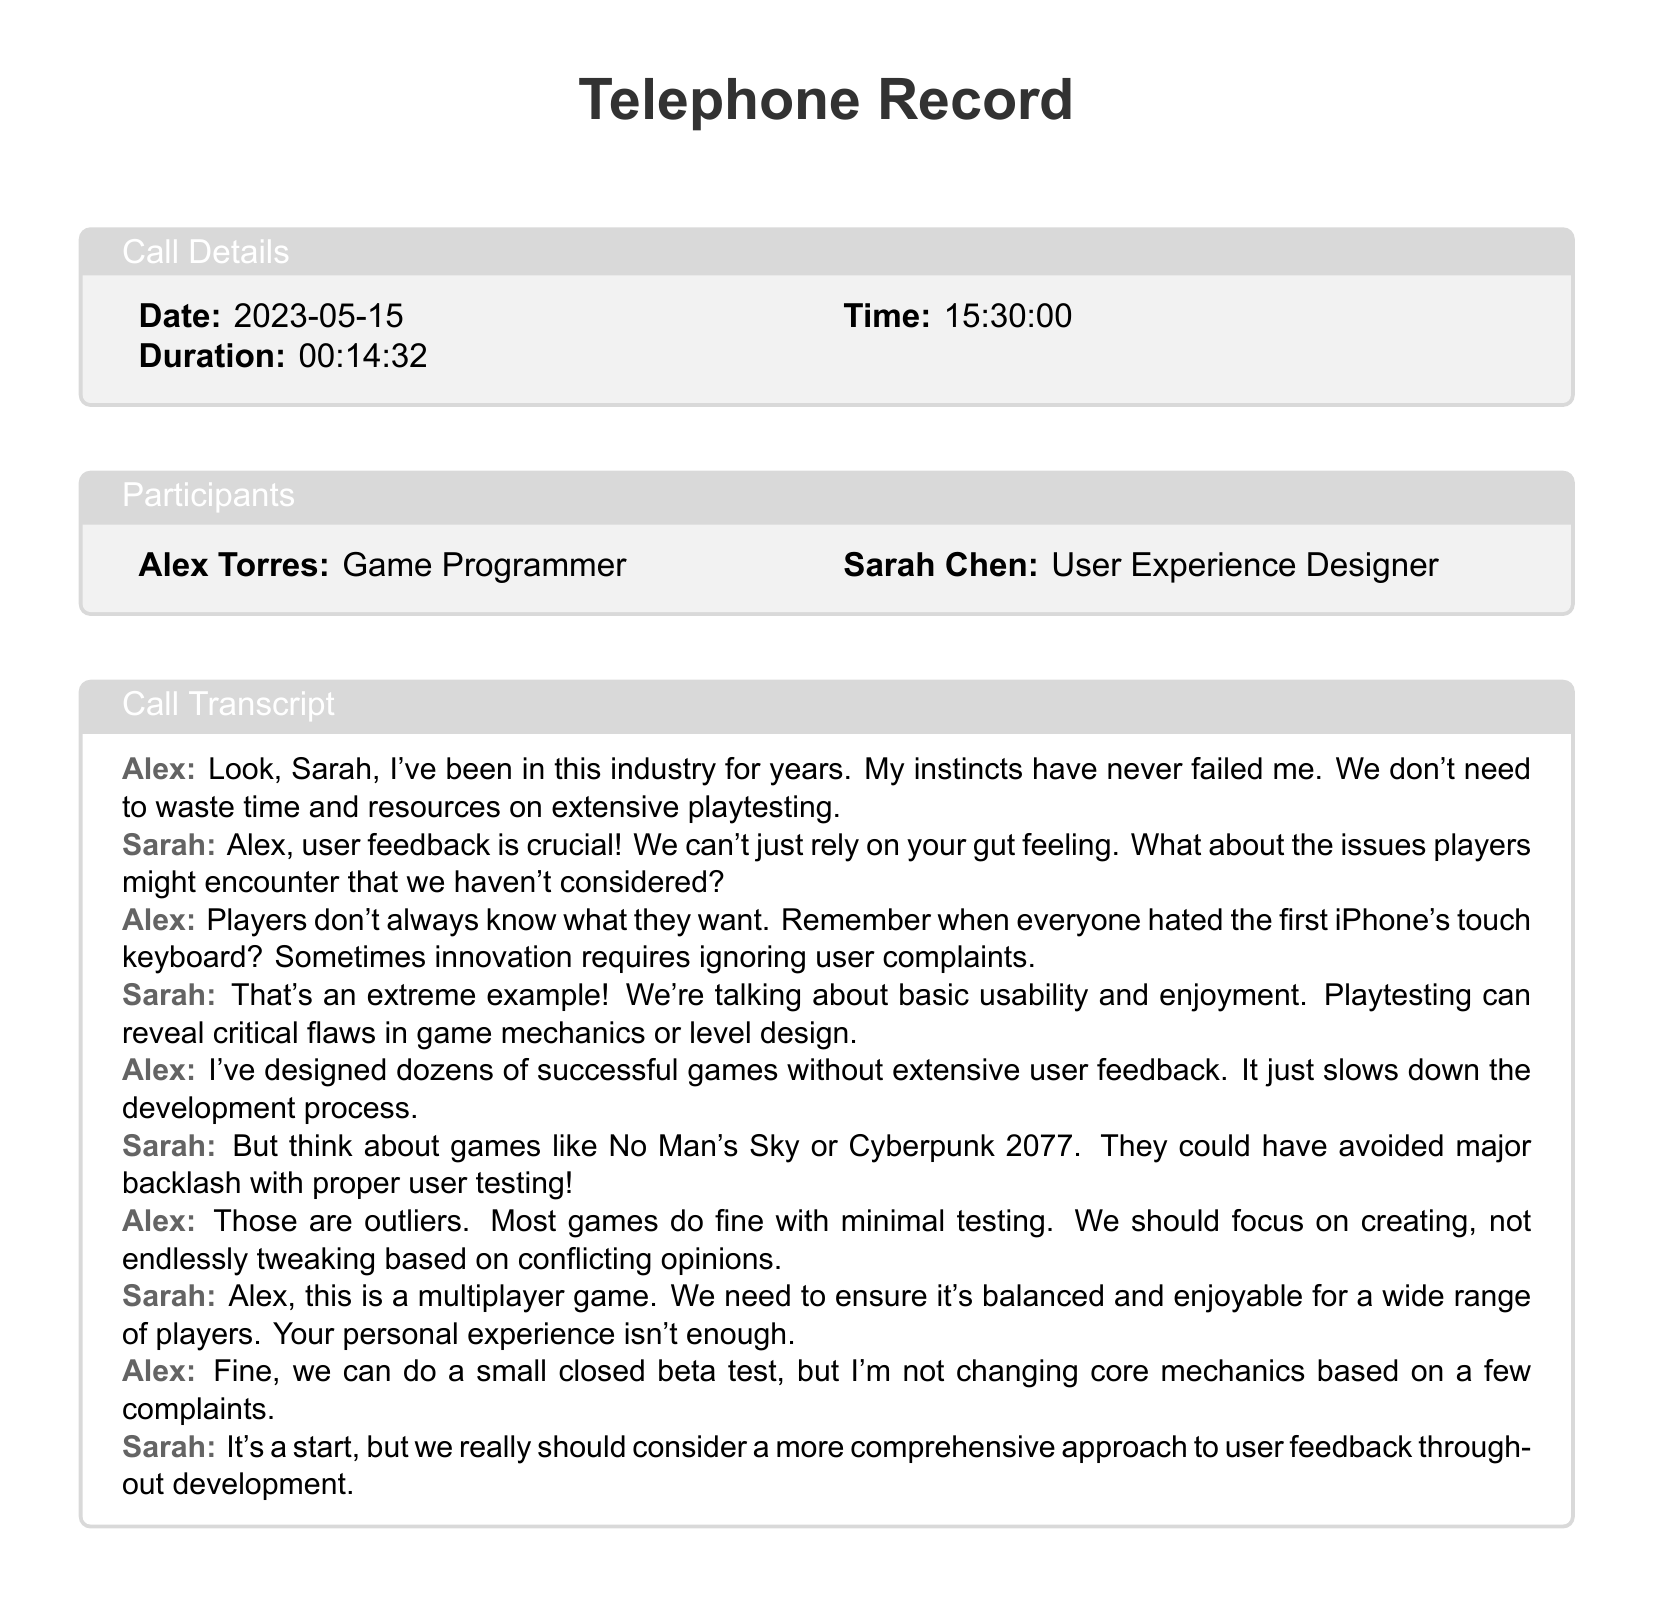What is the date of the call? The date of the call is stated in the call details section of the document.
Answer: 2023-05-15 Who are the participants in the call? The participants are listed in the participants section of the document.
Answer: Alex Torres and Sarah Chen What is the duration of the call? The duration of the call is mentioned in the call details section.
Answer: 00:14:32 What is Alex's profession? Alex's profession is identified in the participants section.
Answer: Game Programmer What major games did Sarah reference to support her argument? Sarah references these games to highlight the importance of user feedback in game development.
Answer: No Man's Sky and Cyberpunk 2077 What does Alex believe about user feedback? Alex expresses his belief about the necessity of user feedback during the argument.
Answer: Overrated What is Sarah's main concern regarding the game development process? Sarah articulates her concern about ensuring balance and enjoyment for players.
Answer: Game balance and enjoyment What approach did Alex agree to consider? Alex suggests a limited testing approach instead of extensive user feedback.
Answer: Closed beta test What does Sarah advocate for throughout development? Sarah emphasizes a more comprehensive strategy regarding user feedback in the development process.
Answer: User feedback 